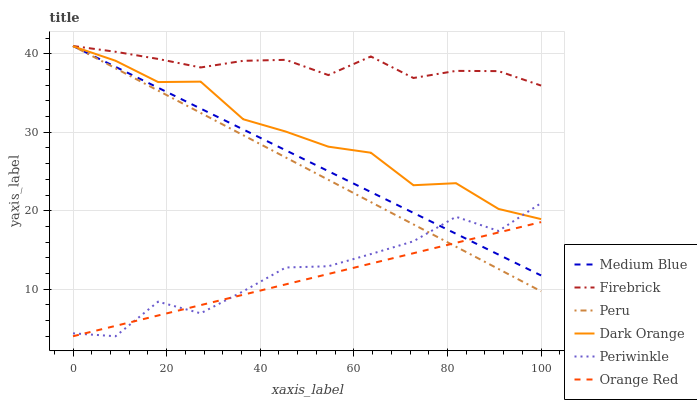Does Orange Red have the minimum area under the curve?
Answer yes or no. Yes. Does Firebrick have the maximum area under the curve?
Answer yes or no. Yes. Does Medium Blue have the minimum area under the curve?
Answer yes or no. No. Does Medium Blue have the maximum area under the curve?
Answer yes or no. No. Is Orange Red the smoothest?
Answer yes or no. Yes. Is Periwinkle the roughest?
Answer yes or no. Yes. Is Firebrick the smoothest?
Answer yes or no. No. Is Firebrick the roughest?
Answer yes or no. No. Does Periwinkle have the lowest value?
Answer yes or no. Yes. Does Medium Blue have the lowest value?
Answer yes or no. No. Does Peru have the highest value?
Answer yes or no. Yes. Does Periwinkle have the highest value?
Answer yes or no. No. Is Orange Red less than Firebrick?
Answer yes or no. Yes. Is Dark Orange greater than Orange Red?
Answer yes or no. Yes. Does Medium Blue intersect Orange Red?
Answer yes or no. Yes. Is Medium Blue less than Orange Red?
Answer yes or no. No. Is Medium Blue greater than Orange Red?
Answer yes or no. No. Does Orange Red intersect Firebrick?
Answer yes or no. No. 